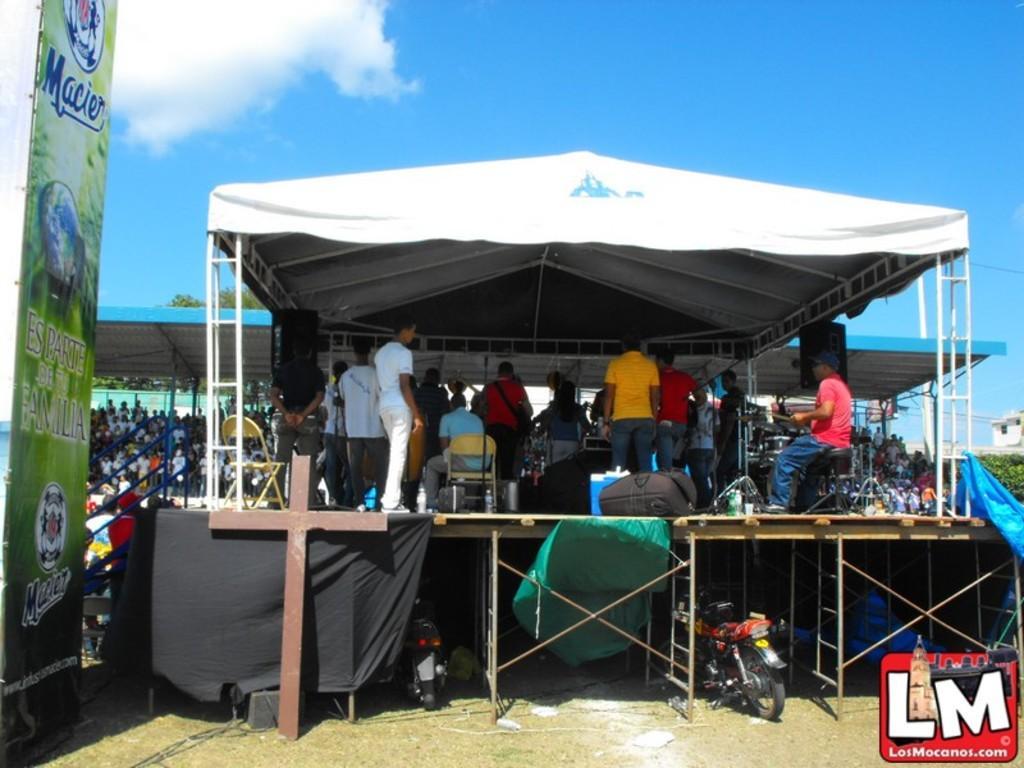Please provide a concise description of this image. In this image we can see a stage. On the stage there are many people. Some are sitting on chairs. Some are standing. Below the stage there are motorcycles. And there are iron rods. On the left side there is a banner. In the background there is a shed. And we can see many people. Also there are railings. In the background there are trees and sky with clouds. In the right bottom corner something is written. 